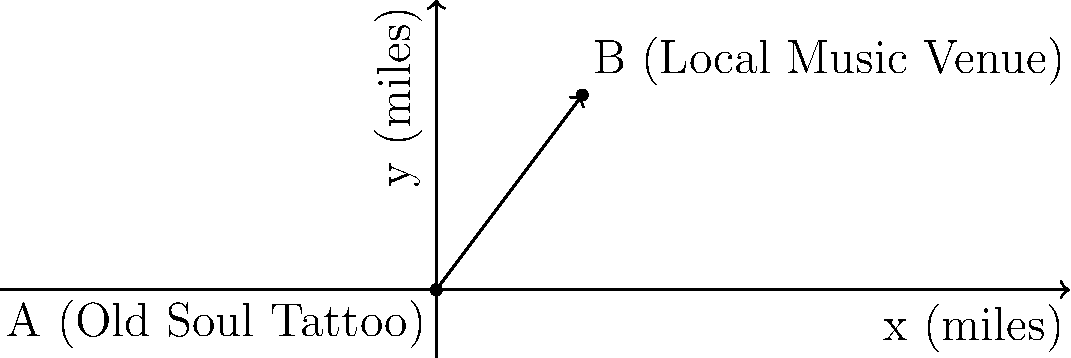You're planning to attend a local music event after getting your latest tattoo at Old Soul Tattoo. The venue is 3 miles east and 4 miles north of the tattoo shop. What is the straight-line distance between Old Soul Tattoo and the music venue? To find the straight-line distance between two points, we can treat the displacement as a vector and calculate its magnitude. Let's approach this step-by-step:

1) The displacement vector from Old Soul Tattoo (point A) to the music venue (point B) is:
   $\vec{v} = (3, 4)$ miles

2) To find the magnitude of this vector, we use the Pythagorean theorem:
   $|\vec{v}| = \sqrt{x^2 + y^2}$

3) Substituting our values:
   $|\vec{v}| = \sqrt{3^2 + 4^2}$

4) Simplify:
   $|\vec{v}| = \sqrt{9 + 16} = \sqrt{25}$

5) Calculate the final result:
   $|\vec{v}| = 5$ miles

Therefore, the straight-line distance between Old Soul Tattoo and the music venue is 5 miles.
Answer: 5 miles 